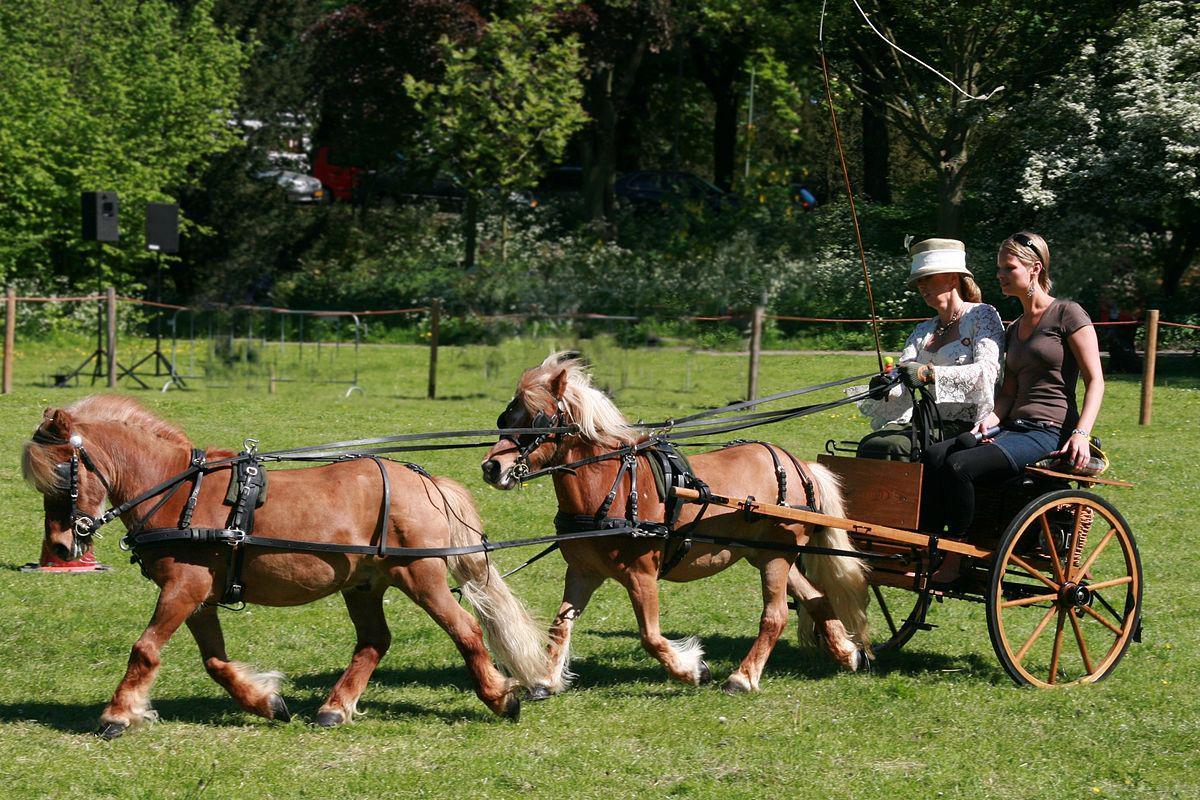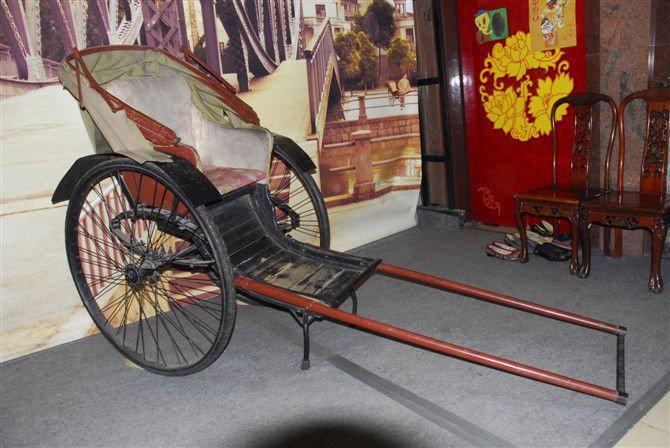The first image is the image on the left, the second image is the image on the right. Given the left and right images, does the statement "All of the carts are being pulled by horses and none of the horses is being ridden by a person." hold true? Answer yes or no. No. The first image is the image on the left, the second image is the image on the right. Analyze the images presented: Is the assertion "There is no more than one person in the left image." valid? Answer yes or no. No. 